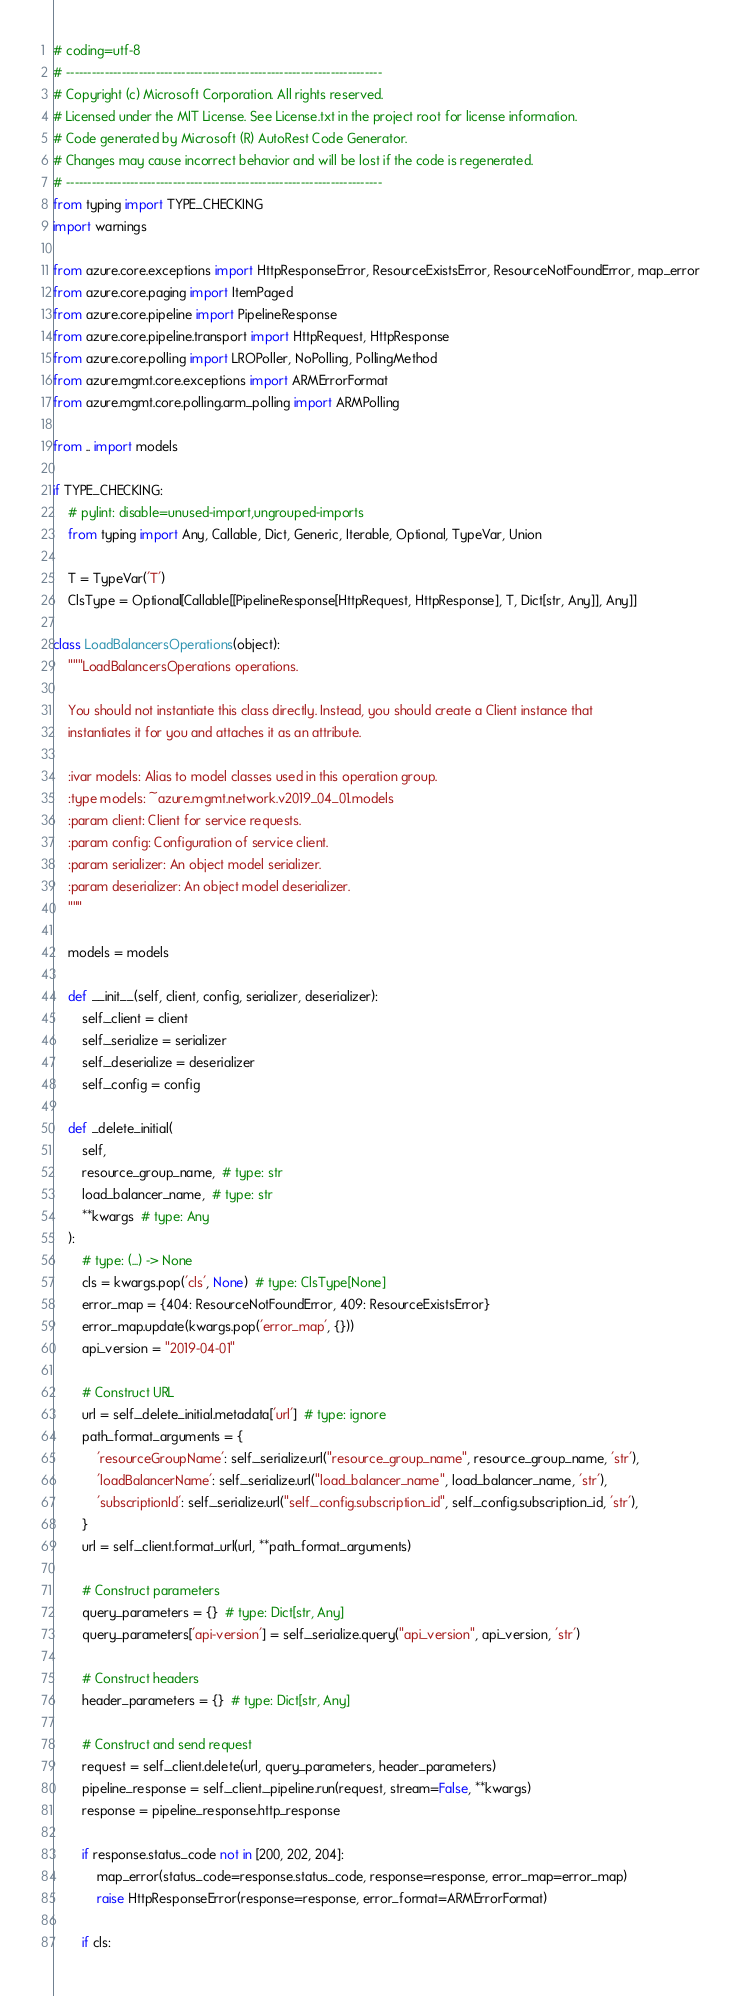Convert code to text. <code><loc_0><loc_0><loc_500><loc_500><_Python_># coding=utf-8
# --------------------------------------------------------------------------
# Copyright (c) Microsoft Corporation. All rights reserved.
# Licensed under the MIT License. See License.txt in the project root for license information.
# Code generated by Microsoft (R) AutoRest Code Generator.
# Changes may cause incorrect behavior and will be lost if the code is regenerated.
# --------------------------------------------------------------------------
from typing import TYPE_CHECKING
import warnings

from azure.core.exceptions import HttpResponseError, ResourceExistsError, ResourceNotFoundError, map_error
from azure.core.paging import ItemPaged
from azure.core.pipeline import PipelineResponse
from azure.core.pipeline.transport import HttpRequest, HttpResponse
from azure.core.polling import LROPoller, NoPolling, PollingMethod
from azure.mgmt.core.exceptions import ARMErrorFormat
from azure.mgmt.core.polling.arm_polling import ARMPolling

from .. import models

if TYPE_CHECKING:
    # pylint: disable=unused-import,ungrouped-imports
    from typing import Any, Callable, Dict, Generic, Iterable, Optional, TypeVar, Union

    T = TypeVar('T')
    ClsType = Optional[Callable[[PipelineResponse[HttpRequest, HttpResponse], T, Dict[str, Any]], Any]]

class LoadBalancersOperations(object):
    """LoadBalancersOperations operations.

    You should not instantiate this class directly. Instead, you should create a Client instance that
    instantiates it for you and attaches it as an attribute.

    :ivar models: Alias to model classes used in this operation group.
    :type models: ~azure.mgmt.network.v2019_04_01.models
    :param client: Client for service requests.
    :param config: Configuration of service client.
    :param serializer: An object model serializer.
    :param deserializer: An object model deserializer.
    """

    models = models

    def __init__(self, client, config, serializer, deserializer):
        self._client = client
        self._serialize = serializer
        self._deserialize = deserializer
        self._config = config

    def _delete_initial(
        self,
        resource_group_name,  # type: str
        load_balancer_name,  # type: str
        **kwargs  # type: Any
    ):
        # type: (...) -> None
        cls = kwargs.pop('cls', None)  # type: ClsType[None]
        error_map = {404: ResourceNotFoundError, 409: ResourceExistsError}
        error_map.update(kwargs.pop('error_map', {}))
        api_version = "2019-04-01"

        # Construct URL
        url = self._delete_initial.metadata['url']  # type: ignore
        path_format_arguments = {
            'resourceGroupName': self._serialize.url("resource_group_name", resource_group_name, 'str'),
            'loadBalancerName': self._serialize.url("load_balancer_name", load_balancer_name, 'str'),
            'subscriptionId': self._serialize.url("self._config.subscription_id", self._config.subscription_id, 'str'),
        }
        url = self._client.format_url(url, **path_format_arguments)

        # Construct parameters
        query_parameters = {}  # type: Dict[str, Any]
        query_parameters['api-version'] = self._serialize.query("api_version", api_version, 'str')

        # Construct headers
        header_parameters = {}  # type: Dict[str, Any]

        # Construct and send request
        request = self._client.delete(url, query_parameters, header_parameters)
        pipeline_response = self._client._pipeline.run(request, stream=False, **kwargs)
        response = pipeline_response.http_response

        if response.status_code not in [200, 202, 204]:
            map_error(status_code=response.status_code, response=response, error_map=error_map)
            raise HttpResponseError(response=response, error_format=ARMErrorFormat)

        if cls:</code> 